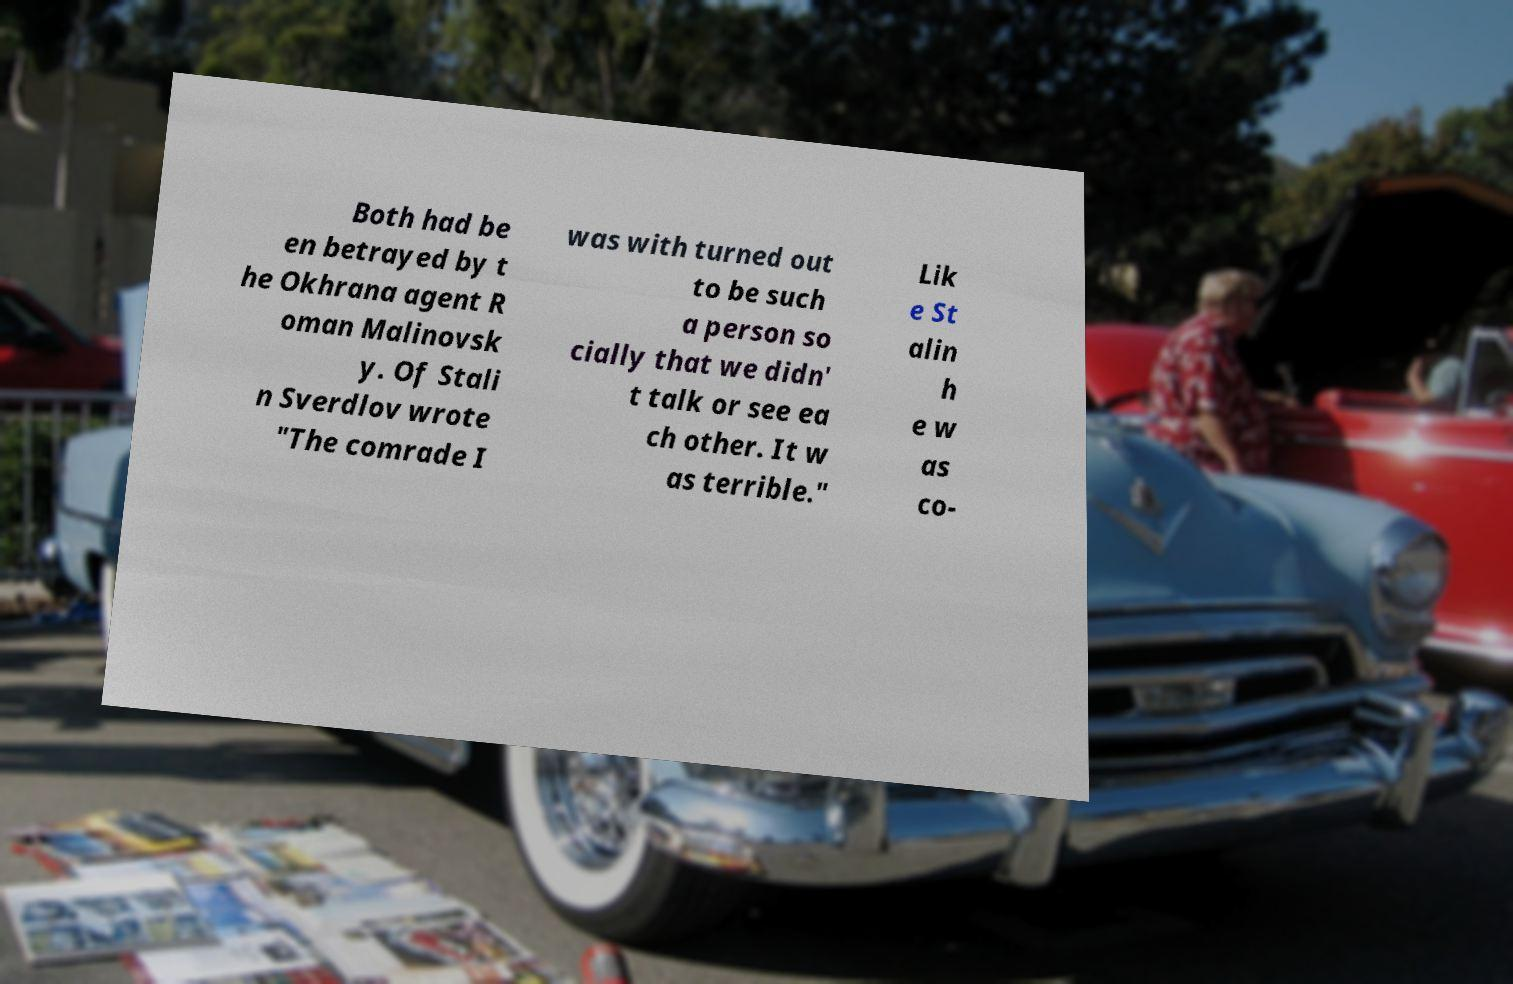Please identify and transcribe the text found in this image. Both had be en betrayed by t he Okhrana agent R oman Malinovsk y. Of Stali n Sverdlov wrote "The comrade I was with turned out to be such a person so cially that we didn' t talk or see ea ch other. It w as terrible." Lik e St alin h e w as co- 